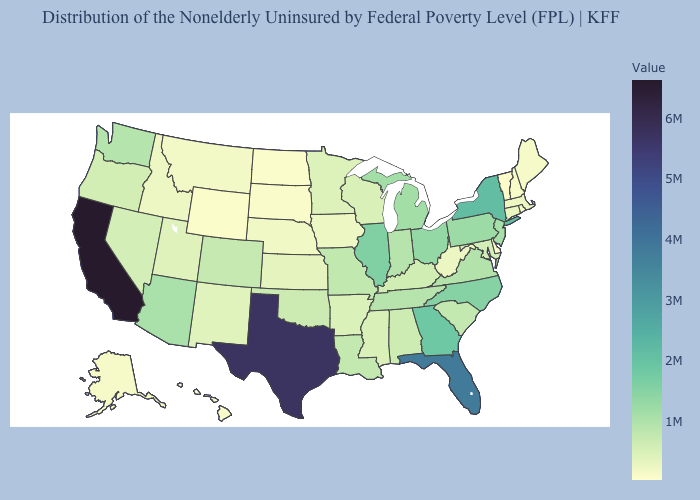Among the states that border South Carolina , does North Carolina have the lowest value?
Quick response, please. Yes. Does Texas have a lower value than California?
Be succinct. Yes. Does the map have missing data?
Quick response, please. No. Which states hav the highest value in the Northeast?
Give a very brief answer. New York. Does Montana have a higher value than Texas?
Be succinct. No. Does California have the highest value in the USA?
Concise answer only. Yes. Among the states that border Iowa , does South Dakota have the lowest value?
Keep it brief. Yes. Which states have the lowest value in the USA?
Quick response, please. Vermont. 